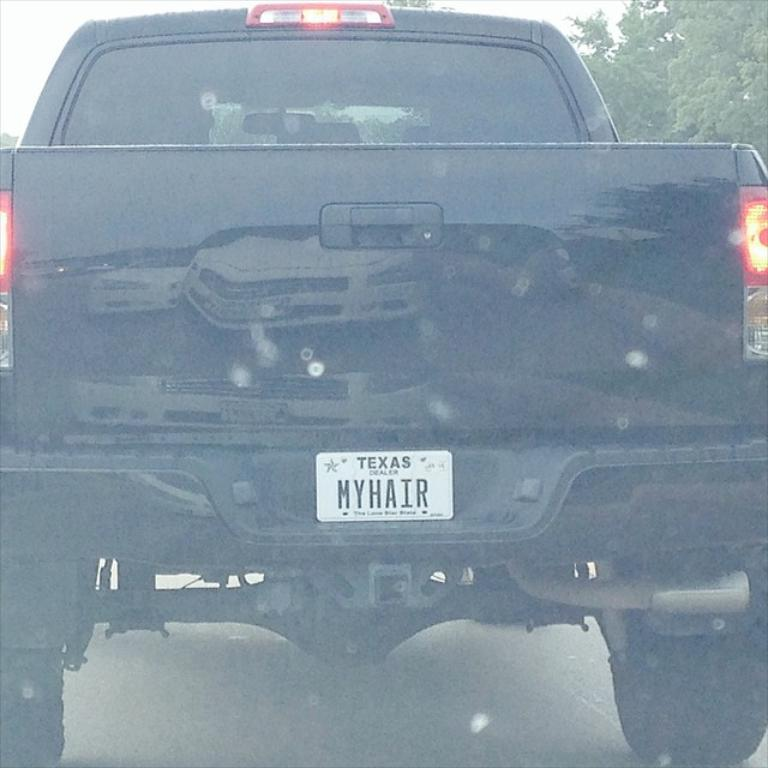What is the main subject of the image? There is a vehicle in the image. What can be used to identify the vehicle? The vehicle has a number plate. What natural element is visible in the image? There are branches of a tree visible in the image. Can you tell me how many jellyfish are swimming near the vehicle in the image? There are no jellyfish present in the image; it features a vehicle and tree branches. What type of cook is preparing a meal in the image? There is no cook or meal preparation present in the image. 